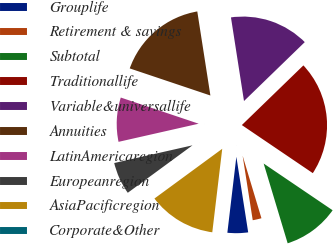<chart> <loc_0><loc_0><loc_500><loc_500><pie_chart><fcel>Grouplife<fcel>Retirement & savings<fcel>Subtotal<fcel>Traditionallife<fcel>Variable&universallife<fcel>Annuities<fcel>LatinAmericaregion<fcel>Europeanregion<fcel>AsiaPacificregion<fcel>Corporate&Other<nl><fcel>4.35%<fcel>2.18%<fcel>10.87%<fcel>21.73%<fcel>15.21%<fcel>17.38%<fcel>8.7%<fcel>6.53%<fcel>13.04%<fcel>0.01%<nl></chart> 